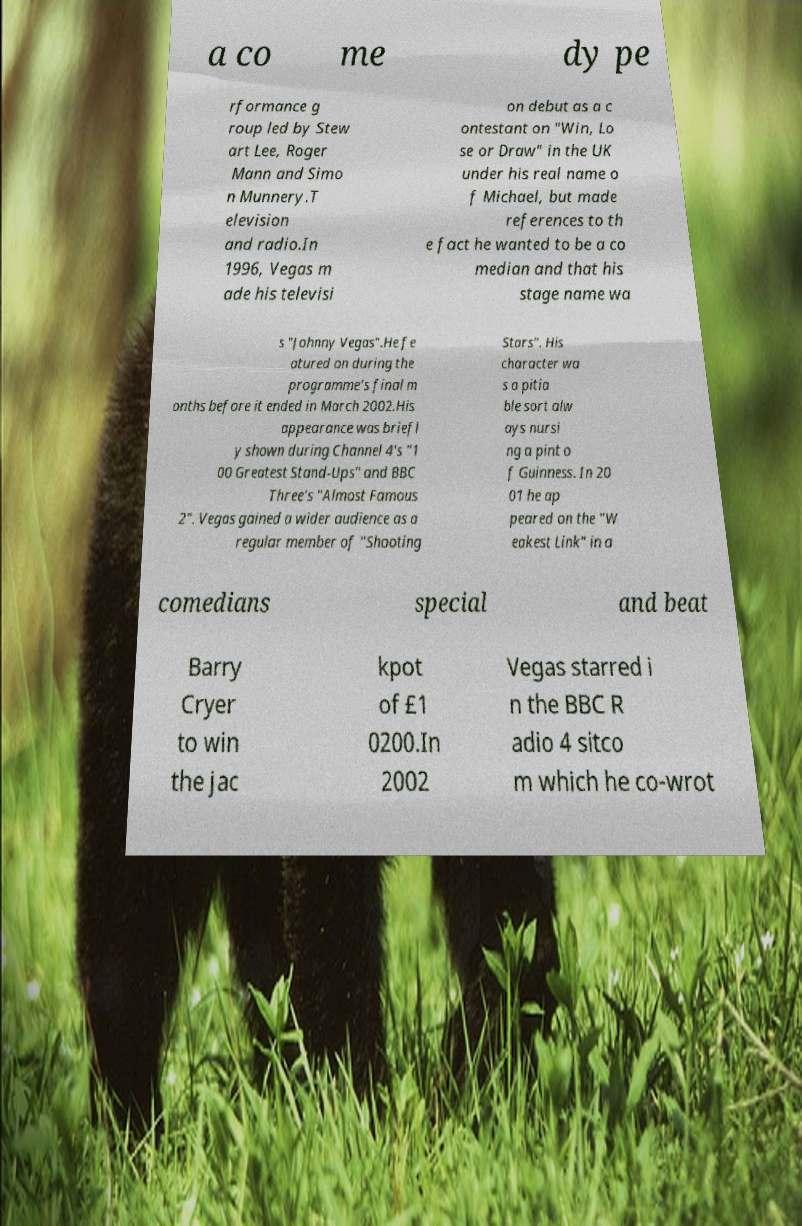Could you assist in decoding the text presented in this image and type it out clearly? a co me dy pe rformance g roup led by Stew art Lee, Roger Mann and Simo n Munnery.T elevision and radio.In 1996, Vegas m ade his televisi on debut as a c ontestant on "Win, Lo se or Draw" in the UK under his real name o f Michael, but made references to th e fact he wanted to be a co median and that his stage name wa s "Johnny Vegas".He fe atured on during the programme's final m onths before it ended in March 2002.His appearance was briefl y shown during Channel 4's "1 00 Greatest Stand-Ups" and BBC Three's "Almost Famous 2". Vegas gained a wider audience as a regular member of "Shooting Stars". His character wa s a pitia ble sort alw ays nursi ng a pint o f Guinness. In 20 01 he ap peared on the "W eakest Link" in a comedians special and beat Barry Cryer to win the jac kpot of £1 0200.In 2002 Vegas starred i n the BBC R adio 4 sitco m which he co-wrot 